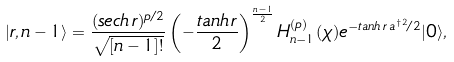Convert formula to latex. <formula><loc_0><loc_0><loc_500><loc_500>| r , n - 1 \rangle = \frac { ( s e c h \, r ) ^ { p / 2 } } { \sqrt { [ n - 1 ] ! } } \left ( - \frac { t a n h \, r } { 2 } \right ) ^ { \frac { n - 1 } { 2 } } H _ { n - 1 } ^ { ( p ) } ( \chi ) e ^ { - t a n h \, r \, a ^ { \dagger 2 } / 2 } | 0 \rangle ,</formula> 